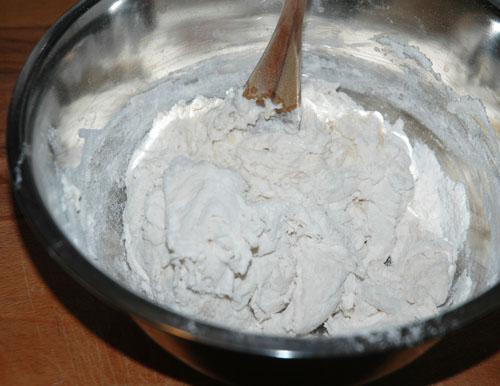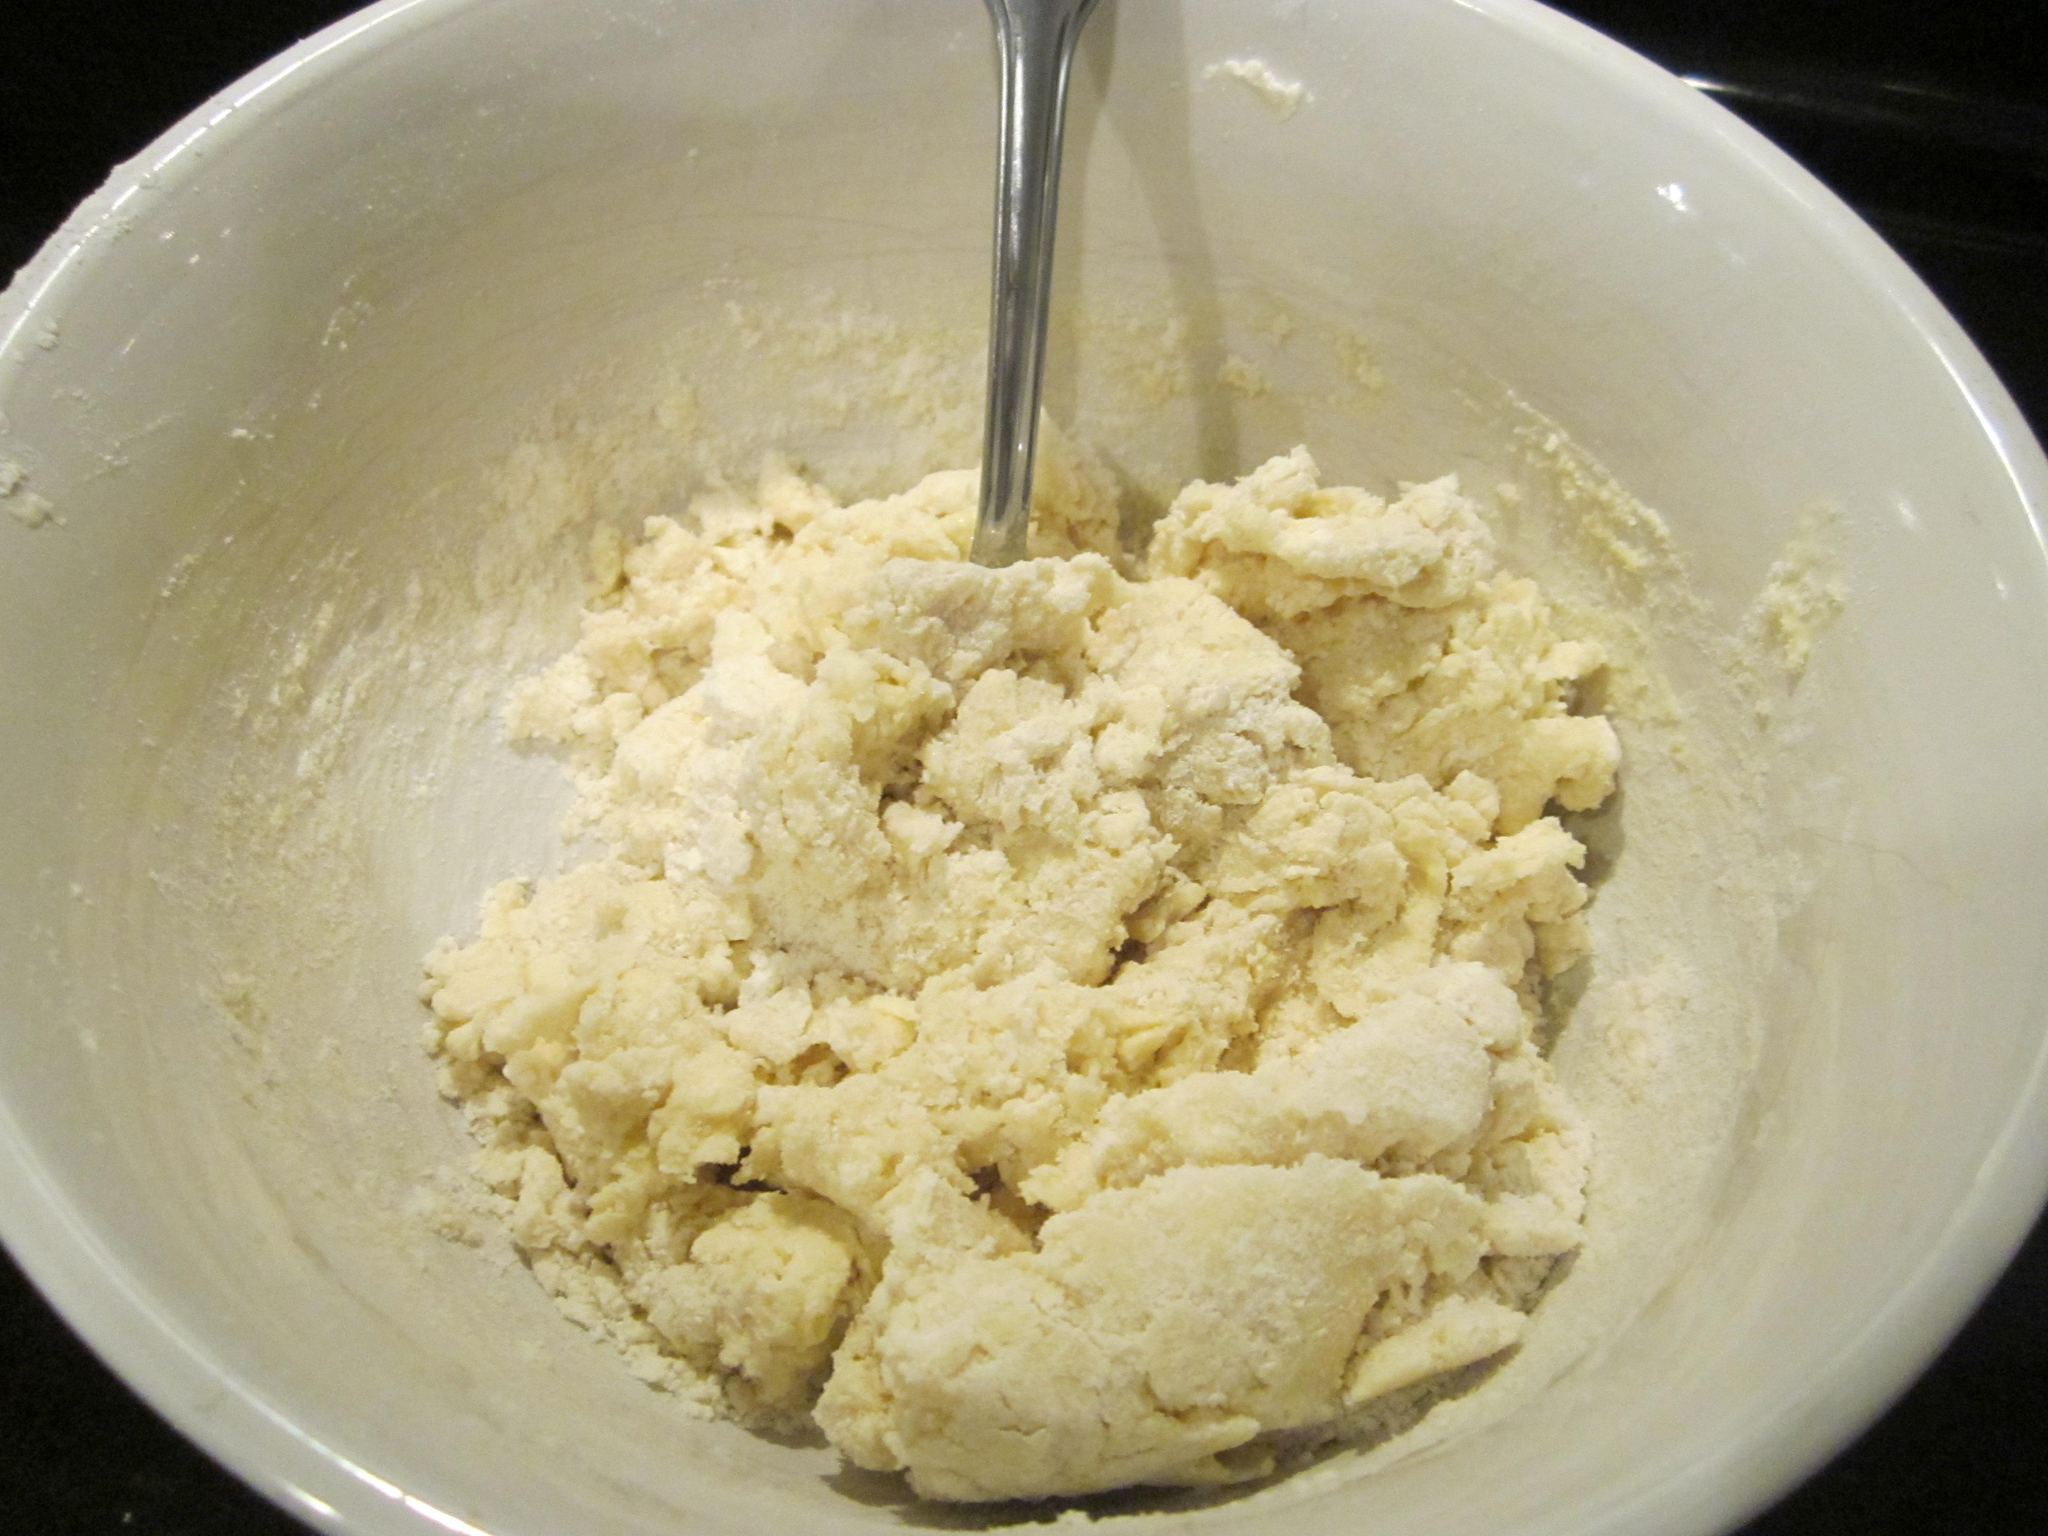The first image is the image on the left, the second image is the image on the right. Assess this claim about the two images: "The left image shows a bowl with dough in it but no utensil, and the right image shows a bowl with a utensil in the dough and its handle sticking out.". Correct or not? Answer yes or no. No. The first image is the image on the left, the second image is the image on the right. Given the left and right images, does the statement "There is a white bowl with dough and a silver utensil is stuck in the dough" hold true? Answer yes or no. Yes. 